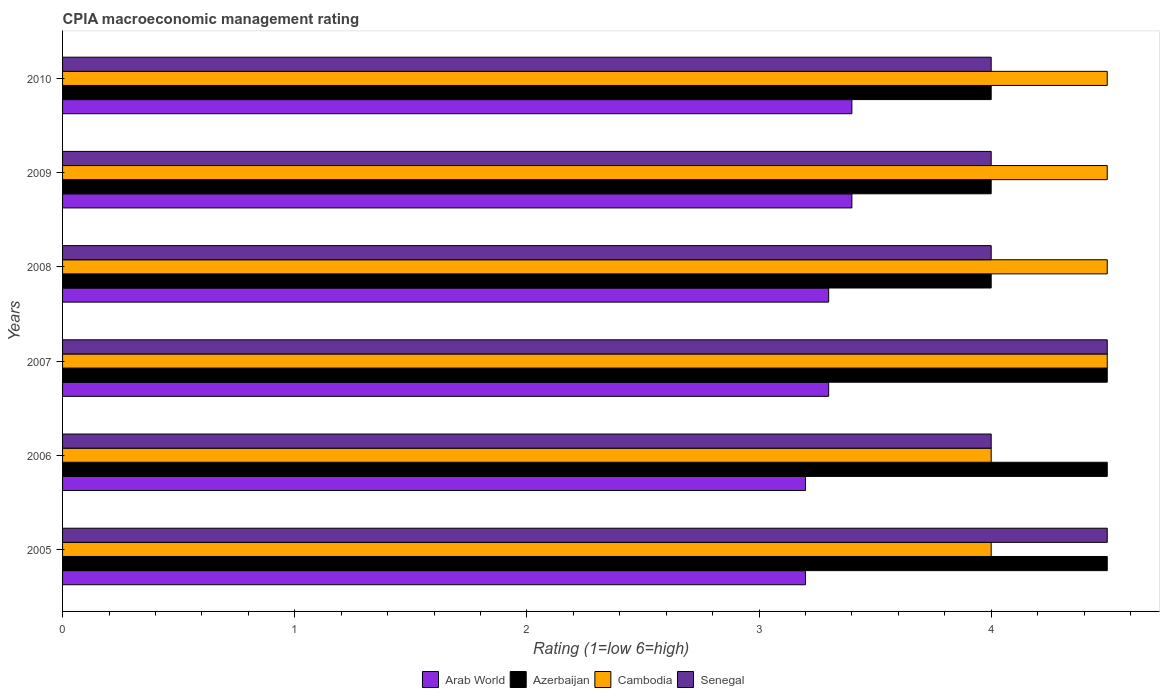How many different coloured bars are there?
Give a very brief answer. 4. How many bars are there on the 2nd tick from the top?
Provide a short and direct response. 4. What is the label of the 3rd group of bars from the top?
Give a very brief answer. 2008. Across all years, what is the minimum CPIA rating in Cambodia?
Your answer should be compact. 4. What is the difference between the CPIA rating in Cambodia in 2006 and that in 2009?
Make the answer very short. -0.5. What is the average CPIA rating in Senegal per year?
Ensure brevity in your answer.  4.17. What is the ratio of the CPIA rating in Arab World in 2008 to that in 2010?
Your answer should be compact. 0.97. Is the CPIA rating in Cambodia in 2006 less than that in 2007?
Your answer should be compact. Yes. What is the difference between the highest and the lowest CPIA rating in Senegal?
Offer a very short reply. 0.5. In how many years, is the CPIA rating in Cambodia greater than the average CPIA rating in Cambodia taken over all years?
Offer a very short reply. 4. Is the sum of the CPIA rating in Azerbaijan in 2009 and 2010 greater than the maximum CPIA rating in Arab World across all years?
Provide a short and direct response. Yes. Is it the case that in every year, the sum of the CPIA rating in Senegal and CPIA rating in Arab World is greater than the sum of CPIA rating in Cambodia and CPIA rating in Azerbaijan?
Your response must be concise. No. What does the 3rd bar from the top in 2008 represents?
Provide a succinct answer. Azerbaijan. What does the 3rd bar from the bottom in 2010 represents?
Your answer should be very brief. Cambodia. How many bars are there?
Your answer should be compact. 24. Are all the bars in the graph horizontal?
Your response must be concise. Yes. Are the values on the major ticks of X-axis written in scientific E-notation?
Make the answer very short. No. Does the graph contain grids?
Provide a short and direct response. No. Where does the legend appear in the graph?
Your answer should be very brief. Bottom center. How many legend labels are there?
Your response must be concise. 4. What is the title of the graph?
Your answer should be very brief. CPIA macroeconomic management rating. Does "Kenya" appear as one of the legend labels in the graph?
Ensure brevity in your answer.  No. What is the label or title of the Y-axis?
Offer a terse response. Years. What is the Rating (1=low 6=high) in Arab World in 2005?
Your answer should be very brief. 3.2. What is the Rating (1=low 6=high) of Arab World in 2006?
Your answer should be very brief. 3.2. What is the Rating (1=low 6=high) of Cambodia in 2006?
Your response must be concise. 4. What is the Rating (1=low 6=high) of Arab World in 2007?
Keep it short and to the point. 3.3. What is the Rating (1=low 6=high) of Cambodia in 2008?
Offer a terse response. 4.5. What is the Rating (1=low 6=high) in Senegal in 2008?
Your answer should be very brief. 4. What is the Rating (1=low 6=high) of Arab World in 2009?
Offer a terse response. 3.4. What is the Rating (1=low 6=high) in Azerbaijan in 2009?
Give a very brief answer. 4. What is the Rating (1=low 6=high) of Cambodia in 2009?
Make the answer very short. 4.5. What is the Rating (1=low 6=high) of Senegal in 2009?
Ensure brevity in your answer.  4. What is the Rating (1=low 6=high) of Arab World in 2010?
Give a very brief answer. 3.4. What is the Rating (1=low 6=high) of Azerbaijan in 2010?
Your answer should be very brief. 4. What is the Rating (1=low 6=high) of Senegal in 2010?
Your answer should be compact. 4. Across all years, what is the maximum Rating (1=low 6=high) in Azerbaijan?
Offer a terse response. 4.5. Across all years, what is the minimum Rating (1=low 6=high) in Arab World?
Your answer should be very brief. 3.2. Across all years, what is the minimum Rating (1=low 6=high) in Senegal?
Offer a very short reply. 4. What is the total Rating (1=low 6=high) of Arab World in the graph?
Provide a succinct answer. 19.8. What is the total Rating (1=low 6=high) of Azerbaijan in the graph?
Your response must be concise. 25.5. What is the total Rating (1=low 6=high) in Senegal in the graph?
Keep it short and to the point. 25. What is the difference between the Rating (1=low 6=high) of Cambodia in 2005 and that in 2006?
Provide a short and direct response. 0. What is the difference between the Rating (1=low 6=high) of Senegal in 2005 and that in 2006?
Ensure brevity in your answer.  0.5. What is the difference between the Rating (1=low 6=high) in Arab World in 2005 and that in 2007?
Offer a terse response. -0.1. What is the difference between the Rating (1=low 6=high) of Azerbaijan in 2005 and that in 2008?
Offer a terse response. 0.5. What is the difference between the Rating (1=low 6=high) in Cambodia in 2005 and that in 2008?
Your answer should be compact. -0.5. What is the difference between the Rating (1=low 6=high) of Senegal in 2005 and that in 2008?
Provide a succinct answer. 0.5. What is the difference between the Rating (1=low 6=high) in Azerbaijan in 2005 and that in 2009?
Provide a short and direct response. 0.5. What is the difference between the Rating (1=low 6=high) of Cambodia in 2005 and that in 2009?
Offer a terse response. -0.5. What is the difference between the Rating (1=low 6=high) in Arab World in 2005 and that in 2010?
Make the answer very short. -0.2. What is the difference between the Rating (1=low 6=high) in Azerbaijan in 2006 and that in 2007?
Make the answer very short. 0. What is the difference between the Rating (1=low 6=high) in Cambodia in 2006 and that in 2007?
Offer a very short reply. -0.5. What is the difference between the Rating (1=low 6=high) of Senegal in 2006 and that in 2007?
Your answer should be compact. -0.5. What is the difference between the Rating (1=low 6=high) of Arab World in 2006 and that in 2008?
Keep it short and to the point. -0.1. What is the difference between the Rating (1=low 6=high) of Senegal in 2006 and that in 2008?
Your answer should be very brief. 0. What is the difference between the Rating (1=low 6=high) of Arab World in 2006 and that in 2009?
Provide a short and direct response. -0.2. What is the difference between the Rating (1=low 6=high) of Azerbaijan in 2006 and that in 2009?
Your answer should be compact. 0.5. What is the difference between the Rating (1=low 6=high) of Arab World in 2006 and that in 2010?
Offer a terse response. -0.2. What is the difference between the Rating (1=low 6=high) in Azerbaijan in 2006 and that in 2010?
Offer a very short reply. 0.5. What is the difference between the Rating (1=low 6=high) in Cambodia in 2006 and that in 2010?
Offer a very short reply. -0.5. What is the difference between the Rating (1=low 6=high) of Senegal in 2006 and that in 2010?
Offer a very short reply. 0. What is the difference between the Rating (1=low 6=high) in Arab World in 2007 and that in 2008?
Offer a terse response. 0. What is the difference between the Rating (1=low 6=high) in Azerbaijan in 2007 and that in 2008?
Your answer should be compact. 0.5. What is the difference between the Rating (1=low 6=high) of Arab World in 2007 and that in 2009?
Offer a very short reply. -0.1. What is the difference between the Rating (1=low 6=high) of Azerbaijan in 2007 and that in 2009?
Offer a very short reply. 0.5. What is the difference between the Rating (1=low 6=high) in Cambodia in 2007 and that in 2009?
Your answer should be very brief. 0. What is the difference between the Rating (1=low 6=high) of Senegal in 2007 and that in 2009?
Your answer should be compact. 0.5. What is the difference between the Rating (1=low 6=high) of Azerbaijan in 2007 and that in 2010?
Your response must be concise. 0.5. What is the difference between the Rating (1=low 6=high) of Arab World in 2008 and that in 2009?
Offer a terse response. -0.1. What is the difference between the Rating (1=low 6=high) in Cambodia in 2008 and that in 2009?
Ensure brevity in your answer.  0. What is the difference between the Rating (1=low 6=high) of Azerbaijan in 2008 and that in 2010?
Your answer should be compact. 0. What is the difference between the Rating (1=low 6=high) of Cambodia in 2008 and that in 2010?
Give a very brief answer. 0. What is the difference between the Rating (1=low 6=high) of Arab World in 2009 and that in 2010?
Offer a terse response. 0. What is the difference between the Rating (1=low 6=high) in Senegal in 2009 and that in 2010?
Your answer should be compact. 0. What is the difference between the Rating (1=low 6=high) of Arab World in 2005 and the Rating (1=low 6=high) of Azerbaijan in 2006?
Your answer should be compact. -1.3. What is the difference between the Rating (1=low 6=high) of Azerbaijan in 2005 and the Rating (1=low 6=high) of Senegal in 2006?
Ensure brevity in your answer.  0.5. What is the difference between the Rating (1=low 6=high) in Arab World in 2005 and the Rating (1=low 6=high) in Senegal in 2007?
Your answer should be very brief. -1.3. What is the difference between the Rating (1=low 6=high) of Azerbaijan in 2005 and the Rating (1=low 6=high) of Cambodia in 2007?
Provide a short and direct response. 0. What is the difference between the Rating (1=low 6=high) of Azerbaijan in 2005 and the Rating (1=low 6=high) of Senegal in 2007?
Your response must be concise. 0. What is the difference between the Rating (1=low 6=high) in Cambodia in 2005 and the Rating (1=low 6=high) in Senegal in 2007?
Offer a very short reply. -0.5. What is the difference between the Rating (1=low 6=high) of Arab World in 2005 and the Rating (1=low 6=high) of Cambodia in 2008?
Your response must be concise. -1.3. What is the difference between the Rating (1=low 6=high) in Arab World in 2005 and the Rating (1=low 6=high) in Senegal in 2008?
Make the answer very short. -0.8. What is the difference between the Rating (1=low 6=high) in Azerbaijan in 2005 and the Rating (1=low 6=high) in Cambodia in 2008?
Offer a terse response. 0. What is the difference between the Rating (1=low 6=high) in Azerbaijan in 2005 and the Rating (1=low 6=high) in Senegal in 2008?
Make the answer very short. 0.5. What is the difference between the Rating (1=low 6=high) in Arab World in 2005 and the Rating (1=low 6=high) in Azerbaijan in 2009?
Offer a terse response. -0.8. What is the difference between the Rating (1=low 6=high) of Arab World in 2005 and the Rating (1=low 6=high) of Cambodia in 2009?
Your answer should be very brief. -1.3. What is the difference between the Rating (1=low 6=high) in Azerbaijan in 2005 and the Rating (1=low 6=high) in Cambodia in 2009?
Your response must be concise. 0. What is the difference between the Rating (1=low 6=high) in Azerbaijan in 2005 and the Rating (1=low 6=high) in Senegal in 2009?
Give a very brief answer. 0.5. What is the difference between the Rating (1=low 6=high) of Arab World in 2005 and the Rating (1=low 6=high) of Azerbaijan in 2010?
Offer a terse response. -0.8. What is the difference between the Rating (1=low 6=high) of Arab World in 2005 and the Rating (1=low 6=high) of Senegal in 2010?
Your answer should be compact. -0.8. What is the difference between the Rating (1=low 6=high) of Azerbaijan in 2005 and the Rating (1=low 6=high) of Cambodia in 2010?
Offer a very short reply. 0. What is the difference between the Rating (1=low 6=high) of Cambodia in 2005 and the Rating (1=low 6=high) of Senegal in 2010?
Ensure brevity in your answer.  0. What is the difference between the Rating (1=low 6=high) in Arab World in 2006 and the Rating (1=low 6=high) in Azerbaijan in 2007?
Make the answer very short. -1.3. What is the difference between the Rating (1=low 6=high) of Arab World in 2006 and the Rating (1=low 6=high) of Cambodia in 2007?
Ensure brevity in your answer.  -1.3. What is the difference between the Rating (1=low 6=high) in Azerbaijan in 2006 and the Rating (1=low 6=high) in Senegal in 2007?
Your response must be concise. 0. What is the difference between the Rating (1=low 6=high) in Cambodia in 2006 and the Rating (1=low 6=high) in Senegal in 2007?
Your answer should be very brief. -0.5. What is the difference between the Rating (1=low 6=high) of Arab World in 2006 and the Rating (1=low 6=high) of Cambodia in 2008?
Keep it short and to the point. -1.3. What is the difference between the Rating (1=low 6=high) in Arab World in 2006 and the Rating (1=low 6=high) in Azerbaijan in 2009?
Your answer should be compact. -0.8. What is the difference between the Rating (1=low 6=high) of Arab World in 2006 and the Rating (1=low 6=high) of Senegal in 2009?
Offer a very short reply. -0.8. What is the difference between the Rating (1=low 6=high) of Azerbaijan in 2006 and the Rating (1=low 6=high) of Cambodia in 2009?
Ensure brevity in your answer.  0. What is the difference between the Rating (1=low 6=high) of Azerbaijan in 2006 and the Rating (1=low 6=high) of Senegal in 2009?
Provide a succinct answer. 0.5. What is the difference between the Rating (1=low 6=high) in Cambodia in 2006 and the Rating (1=low 6=high) in Senegal in 2009?
Ensure brevity in your answer.  0. What is the difference between the Rating (1=low 6=high) of Arab World in 2006 and the Rating (1=low 6=high) of Azerbaijan in 2010?
Give a very brief answer. -0.8. What is the difference between the Rating (1=low 6=high) in Azerbaijan in 2006 and the Rating (1=low 6=high) in Cambodia in 2010?
Provide a short and direct response. 0. What is the difference between the Rating (1=low 6=high) in Azerbaijan in 2006 and the Rating (1=low 6=high) in Senegal in 2010?
Your answer should be compact. 0.5. What is the difference between the Rating (1=low 6=high) in Cambodia in 2006 and the Rating (1=low 6=high) in Senegal in 2010?
Make the answer very short. 0. What is the difference between the Rating (1=low 6=high) in Arab World in 2007 and the Rating (1=low 6=high) in Azerbaijan in 2008?
Provide a short and direct response. -0.7. What is the difference between the Rating (1=low 6=high) in Azerbaijan in 2007 and the Rating (1=low 6=high) in Senegal in 2008?
Provide a short and direct response. 0.5. What is the difference between the Rating (1=low 6=high) of Cambodia in 2007 and the Rating (1=low 6=high) of Senegal in 2008?
Your answer should be very brief. 0.5. What is the difference between the Rating (1=low 6=high) of Arab World in 2007 and the Rating (1=low 6=high) of Cambodia in 2009?
Give a very brief answer. -1.2. What is the difference between the Rating (1=low 6=high) in Arab World in 2007 and the Rating (1=low 6=high) in Senegal in 2009?
Your response must be concise. -0.7. What is the difference between the Rating (1=low 6=high) of Azerbaijan in 2007 and the Rating (1=low 6=high) of Cambodia in 2009?
Give a very brief answer. 0. What is the difference between the Rating (1=low 6=high) of Azerbaijan in 2007 and the Rating (1=low 6=high) of Senegal in 2009?
Your answer should be very brief. 0.5. What is the difference between the Rating (1=low 6=high) in Cambodia in 2007 and the Rating (1=low 6=high) in Senegal in 2009?
Provide a short and direct response. 0.5. What is the difference between the Rating (1=low 6=high) of Arab World in 2007 and the Rating (1=low 6=high) of Senegal in 2010?
Give a very brief answer. -0.7. What is the difference between the Rating (1=low 6=high) of Azerbaijan in 2007 and the Rating (1=low 6=high) of Senegal in 2010?
Keep it short and to the point. 0.5. What is the difference between the Rating (1=low 6=high) in Arab World in 2008 and the Rating (1=low 6=high) in Azerbaijan in 2009?
Offer a terse response. -0.7. What is the difference between the Rating (1=low 6=high) in Arab World in 2008 and the Rating (1=low 6=high) in Cambodia in 2009?
Your answer should be very brief. -1.2. What is the difference between the Rating (1=low 6=high) of Azerbaijan in 2008 and the Rating (1=low 6=high) of Senegal in 2009?
Give a very brief answer. 0. What is the difference between the Rating (1=low 6=high) of Cambodia in 2008 and the Rating (1=low 6=high) of Senegal in 2009?
Provide a succinct answer. 0.5. What is the difference between the Rating (1=low 6=high) in Arab World in 2008 and the Rating (1=low 6=high) in Azerbaijan in 2010?
Give a very brief answer. -0.7. What is the difference between the Rating (1=low 6=high) in Arab World in 2008 and the Rating (1=low 6=high) in Cambodia in 2010?
Your response must be concise. -1.2. What is the difference between the Rating (1=low 6=high) in Arab World in 2008 and the Rating (1=low 6=high) in Senegal in 2010?
Provide a short and direct response. -0.7. What is the difference between the Rating (1=low 6=high) in Cambodia in 2008 and the Rating (1=low 6=high) in Senegal in 2010?
Make the answer very short. 0.5. What is the difference between the Rating (1=low 6=high) in Arab World in 2009 and the Rating (1=low 6=high) in Cambodia in 2010?
Keep it short and to the point. -1.1. What is the difference between the Rating (1=low 6=high) in Arab World in 2009 and the Rating (1=low 6=high) in Senegal in 2010?
Ensure brevity in your answer.  -0.6. What is the difference between the Rating (1=low 6=high) of Azerbaijan in 2009 and the Rating (1=low 6=high) of Senegal in 2010?
Your answer should be very brief. 0. What is the average Rating (1=low 6=high) in Azerbaijan per year?
Provide a succinct answer. 4.25. What is the average Rating (1=low 6=high) of Cambodia per year?
Provide a short and direct response. 4.33. What is the average Rating (1=low 6=high) of Senegal per year?
Give a very brief answer. 4.17. In the year 2005, what is the difference between the Rating (1=low 6=high) in Arab World and Rating (1=low 6=high) in Azerbaijan?
Keep it short and to the point. -1.3. In the year 2005, what is the difference between the Rating (1=low 6=high) in Arab World and Rating (1=low 6=high) in Senegal?
Provide a succinct answer. -1.3. In the year 2005, what is the difference between the Rating (1=low 6=high) in Azerbaijan and Rating (1=low 6=high) in Cambodia?
Provide a short and direct response. 0.5. In the year 2005, what is the difference between the Rating (1=low 6=high) in Azerbaijan and Rating (1=low 6=high) in Senegal?
Provide a succinct answer. 0. In the year 2005, what is the difference between the Rating (1=low 6=high) in Cambodia and Rating (1=low 6=high) in Senegal?
Offer a terse response. -0.5. In the year 2006, what is the difference between the Rating (1=low 6=high) of Azerbaijan and Rating (1=low 6=high) of Cambodia?
Your answer should be compact. 0.5. In the year 2006, what is the difference between the Rating (1=low 6=high) in Cambodia and Rating (1=low 6=high) in Senegal?
Offer a very short reply. 0. In the year 2007, what is the difference between the Rating (1=low 6=high) of Arab World and Rating (1=low 6=high) of Cambodia?
Your answer should be very brief. -1.2. In the year 2007, what is the difference between the Rating (1=low 6=high) in Arab World and Rating (1=low 6=high) in Senegal?
Provide a succinct answer. -1.2. In the year 2007, what is the difference between the Rating (1=low 6=high) in Azerbaijan and Rating (1=low 6=high) in Cambodia?
Make the answer very short. 0. In the year 2008, what is the difference between the Rating (1=low 6=high) of Arab World and Rating (1=low 6=high) of Azerbaijan?
Your answer should be very brief. -0.7. In the year 2008, what is the difference between the Rating (1=low 6=high) in Arab World and Rating (1=low 6=high) in Cambodia?
Keep it short and to the point. -1.2. In the year 2008, what is the difference between the Rating (1=low 6=high) in Azerbaijan and Rating (1=low 6=high) in Senegal?
Make the answer very short. 0. In the year 2008, what is the difference between the Rating (1=low 6=high) of Cambodia and Rating (1=low 6=high) of Senegal?
Make the answer very short. 0.5. In the year 2009, what is the difference between the Rating (1=low 6=high) in Arab World and Rating (1=low 6=high) in Cambodia?
Your answer should be compact. -1.1. In the year 2009, what is the difference between the Rating (1=low 6=high) in Arab World and Rating (1=low 6=high) in Senegal?
Offer a terse response. -0.6. In the year 2009, what is the difference between the Rating (1=low 6=high) in Azerbaijan and Rating (1=low 6=high) in Cambodia?
Offer a very short reply. -0.5. In the year 2009, what is the difference between the Rating (1=low 6=high) of Cambodia and Rating (1=low 6=high) of Senegal?
Give a very brief answer. 0.5. In the year 2010, what is the difference between the Rating (1=low 6=high) of Arab World and Rating (1=low 6=high) of Azerbaijan?
Provide a short and direct response. -0.6. In the year 2010, what is the difference between the Rating (1=low 6=high) of Arab World and Rating (1=low 6=high) of Senegal?
Provide a succinct answer. -0.6. What is the ratio of the Rating (1=low 6=high) in Arab World in 2005 to that in 2006?
Your answer should be compact. 1. What is the ratio of the Rating (1=low 6=high) of Senegal in 2005 to that in 2006?
Offer a very short reply. 1.12. What is the ratio of the Rating (1=low 6=high) of Arab World in 2005 to that in 2007?
Give a very brief answer. 0.97. What is the ratio of the Rating (1=low 6=high) of Azerbaijan in 2005 to that in 2007?
Keep it short and to the point. 1. What is the ratio of the Rating (1=low 6=high) in Arab World in 2005 to that in 2008?
Give a very brief answer. 0.97. What is the ratio of the Rating (1=low 6=high) of Senegal in 2005 to that in 2008?
Your answer should be very brief. 1.12. What is the ratio of the Rating (1=low 6=high) in Arab World in 2005 to that in 2009?
Ensure brevity in your answer.  0.94. What is the ratio of the Rating (1=low 6=high) of Azerbaijan in 2005 to that in 2009?
Keep it short and to the point. 1.12. What is the ratio of the Rating (1=low 6=high) of Arab World in 2005 to that in 2010?
Ensure brevity in your answer.  0.94. What is the ratio of the Rating (1=low 6=high) of Cambodia in 2005 to that in 2010?
Your answer should be compact. 0.89. What is the ratio of the Rating (1=low 6=high) of Arab World in 2006 to that in 2007?
Ensure brevity in your answer.  0.97. What is the ratio of the Rating (1=low 6=high) in Azerbaijan in 2006 to that in 2007?
Provide a short and direct response. 1. What is the ratio of the Rating (1=low 6=high) of Senegal in 2006 to that in 2007?
Offer a very short reply. 0.89. What is the ratio of the Rating (1=low 6=high) in Arab World in 2006 to that in 2008?
Ensure brevity in your answer.  0.97. What is the ratio of the Rating (1=low 6=high) in Cambodia in 2006 to that in 2008?
Offer a very short reply. 0.89. What is the ratio of the Rating (1=low 6=high) of Senegal in 2006 to that in 2008?
Ensure brevity in your answer.  1. What is the ratio of the Rating (1=low 6=high) of Arab World in 2006 to that in 2009?
Make the answer very short. 0.94. What is the ratio of the Rating (1=low 6=high) in Senegal in 2006 to that in 2009?
Keep it short and to the point. 1. What is the ratio of the Rating (1=low 6=high) in Cambodia in 2006 to that in 2010?
Ensure brevity in your answer.  0.89. What is the ratio of the Rating (1=low 6=high) of Arab World in 2007 to that in 2008?
Give a very brief answer. 1. What is the ratio of the Rating (1=low 6=high) of Azerbaijan in 2007 to that in 2008?
Ensure brevity in your answer.  1.12. What is the ratio of the Rating (1=low 6=high) of Cambodia in 2007 to that in 2008?
Your response must be concise. 1. What is the ratio of the Rating (1=low 6=high) in Senegal in 2007 to that in 2008?
Give a very brief answer. 1.12. What is the ratio of the Rating (1=low 6=high) in Arab World in 2007 to that in 2009?
Offer a terse response. 0.97. What is the ratio of the Rating (1=low 6=high) of Azerbaijan in 2007 to that in 2009?
Offer a terse response. 1.12. What is the ratio of the Rating (1=low 6=high) of Arab World in 2007 to that in 2010?
Keep it short and to the point. 0.97. What is the ratio of the Rating (1=low 6=high) of Cambodia in 2007 to that in 2010?
Provide a succinct answer. 1. What is the ratio of the Rating (1=low 6=high) in Arab World in 2008 to that in 2009?
Keep it short and to the point. 0.97. What is the ratio of the Rating (1=low 6=high) in Azerbaijan in 2008 to that in 2009?
Offer a terse response. 1. What is the ratio of the Rating (1=low 6=high) of Cambodia in 2008 to that in 2009?
Offer a terse response. 1. What is the ratio of the Rating (1=low 6=high) in Senegal in 2008 to that in 2009?
Your response must be concise. 1. What is the ratio of the Rating (1=low 6=high) of Arab World in 2008 to that in 2010?
Provide a short and direct response. 0.97. What is the ratio of the Rating (1=low 6=high) of Arab World in 2009 to that in 2010?
Offer a terse response. 1. What is the ratio of the Rating (1=low 6=high) in Azerbaijan in 2009 to that in 2010?
Your answer should be very brief. 1. What is the ratio of the Rating (1=low 6=high) of Cambodia in 2009 to that in 2010?
Your response must be concise. 1. What is the difference between the highest and the second highest Rating (1=low 6=high) of Arab World?
Ensure brevity in your answer.  0. What is the difference between the highest and the second highest Rating (1=low 6=high) of Azerbaijan?
Your answer should be very brief. 0. What is the difference between the highest and the lowest Rating (1=low 6=high) of Cambodia?
Ensure brevity in your answer.  0.5. 